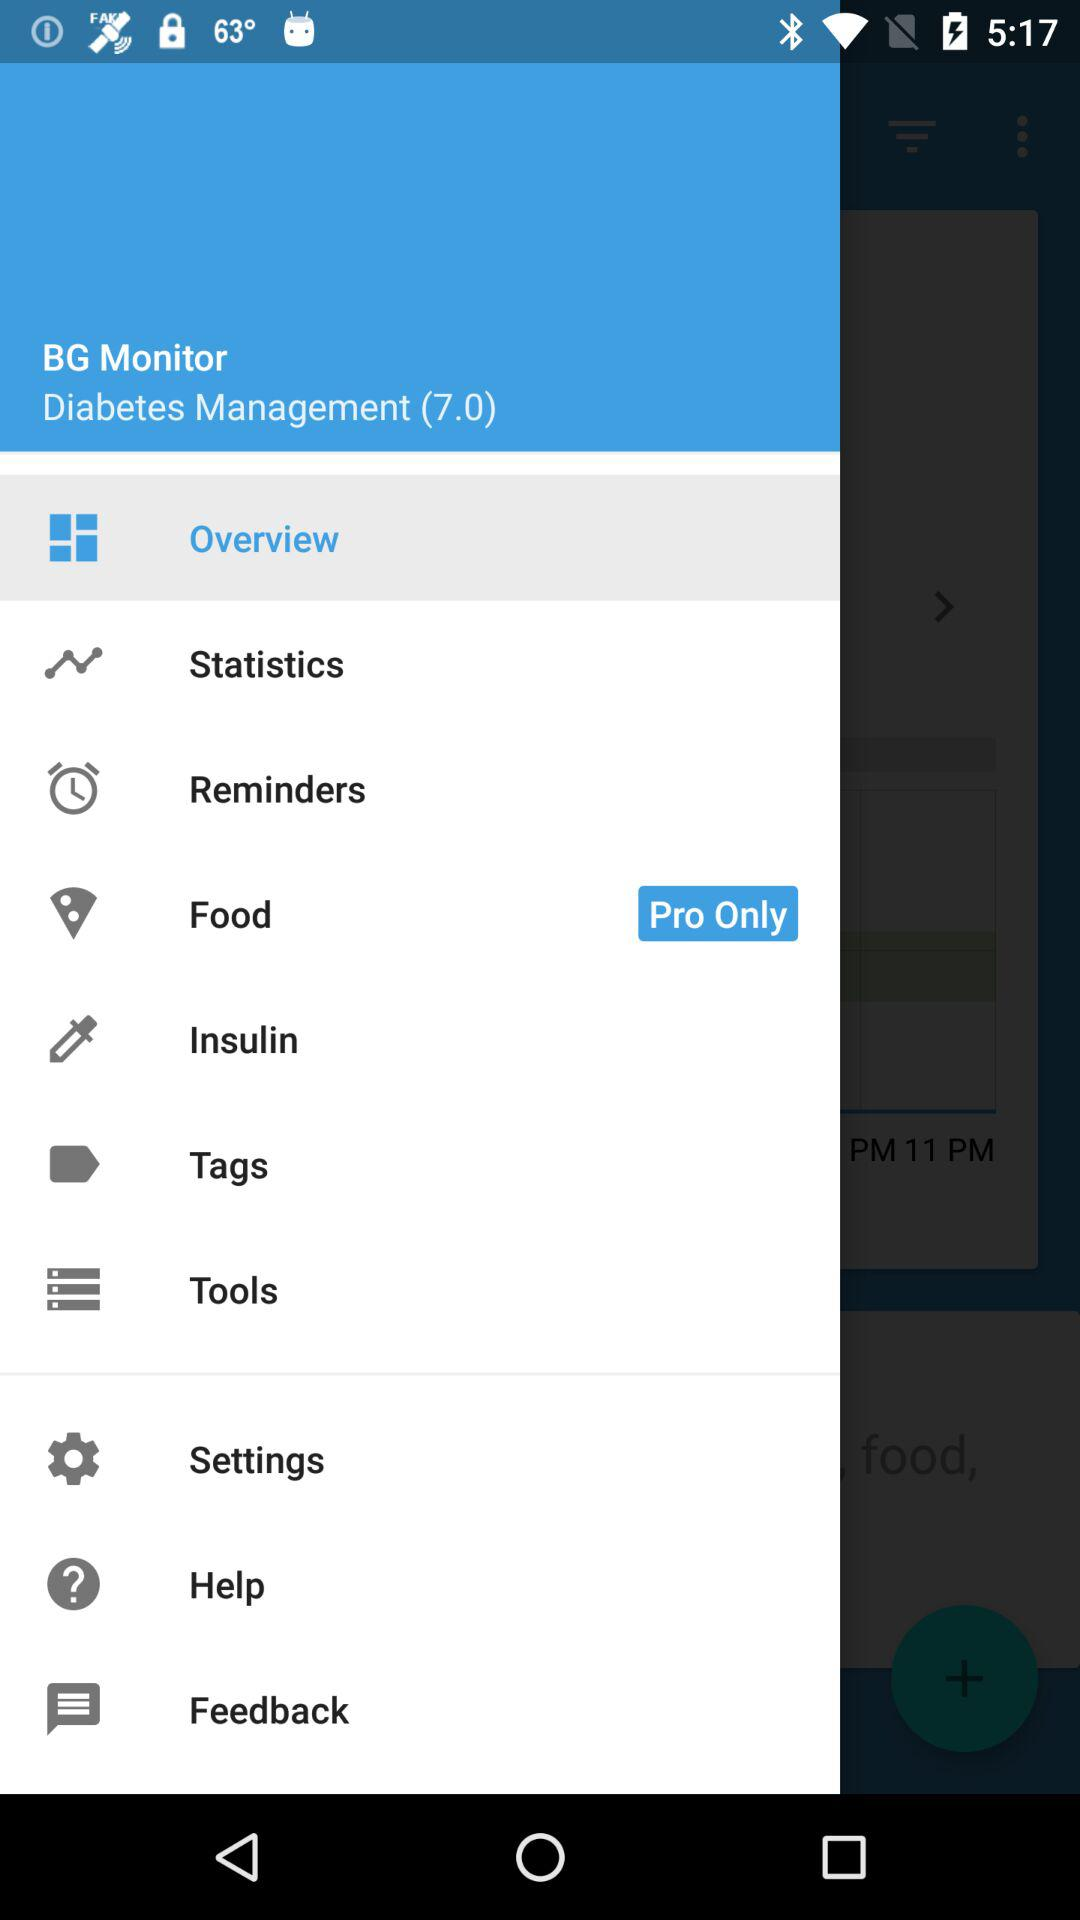Which option is for "Pro Only"? The option for "Pro Only" is "Food". 